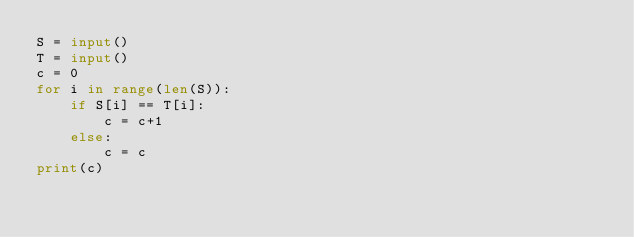<code> <loc_0><loc_0><loc_500><loc_500><_Python_>S = input()
T = input()
c = 0
for i in range(len(S)):
    if S[i] == T[i]:
        c = c+1
    else:
        c = c
print(c)</code> 